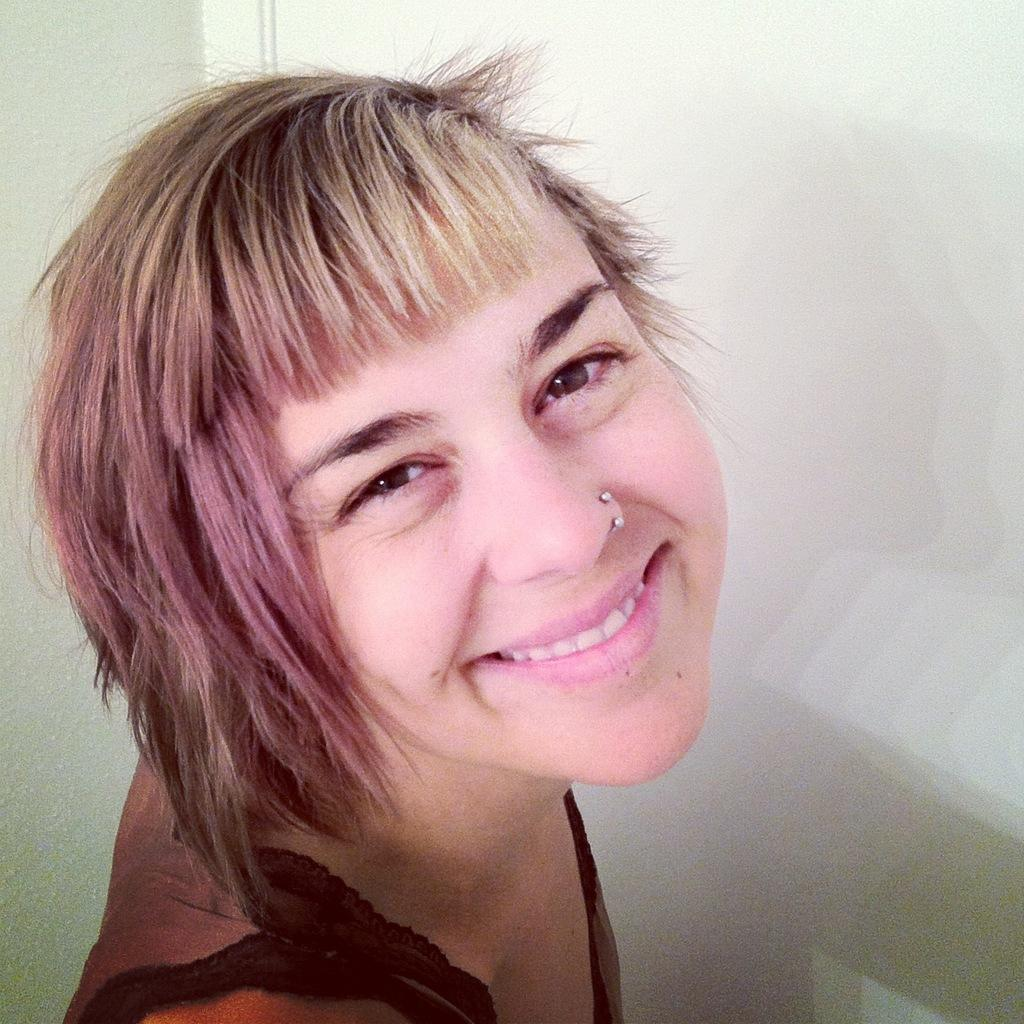Who is the main subject in the image? There is a lady in the image. What is the lady doing in the image? The lady is smiling. Are there any accessories visible on the lady? Yes, the lady has a nose ring on her nose. What is the color of the background in the image? The background in the image is white. What type of leather is the lady using to measure the milk in the image? There is no leather or milk present in the image; it only features a lady with a nose ring and a white background. 